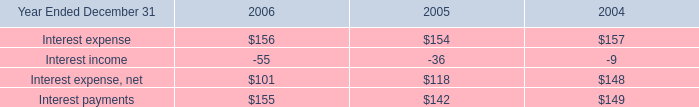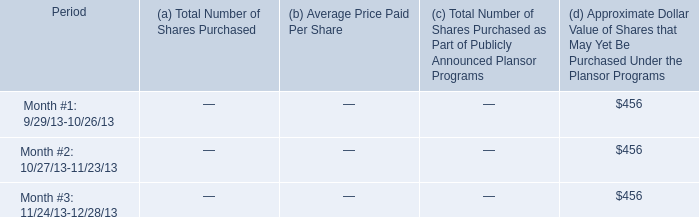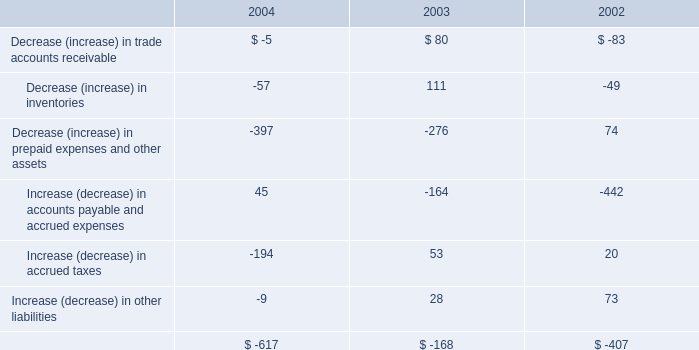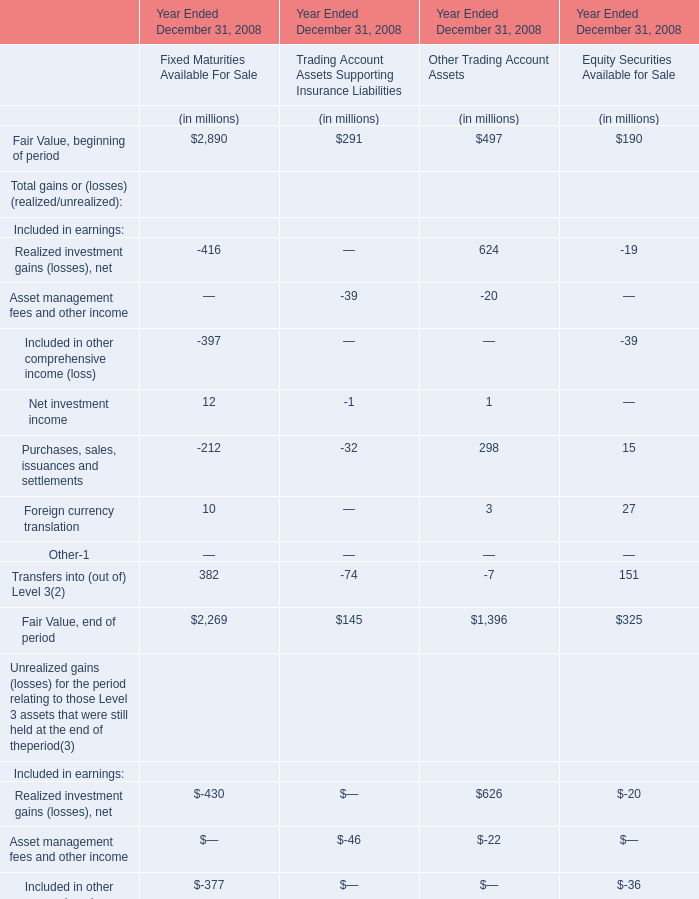What is the amount of Net investment income and Purchases, sales, issuances and settlements in the section with the most Fixed Maturities Available For Sale ? (in million) 
Computations: (12 - 212)
Answer: -200.0. 